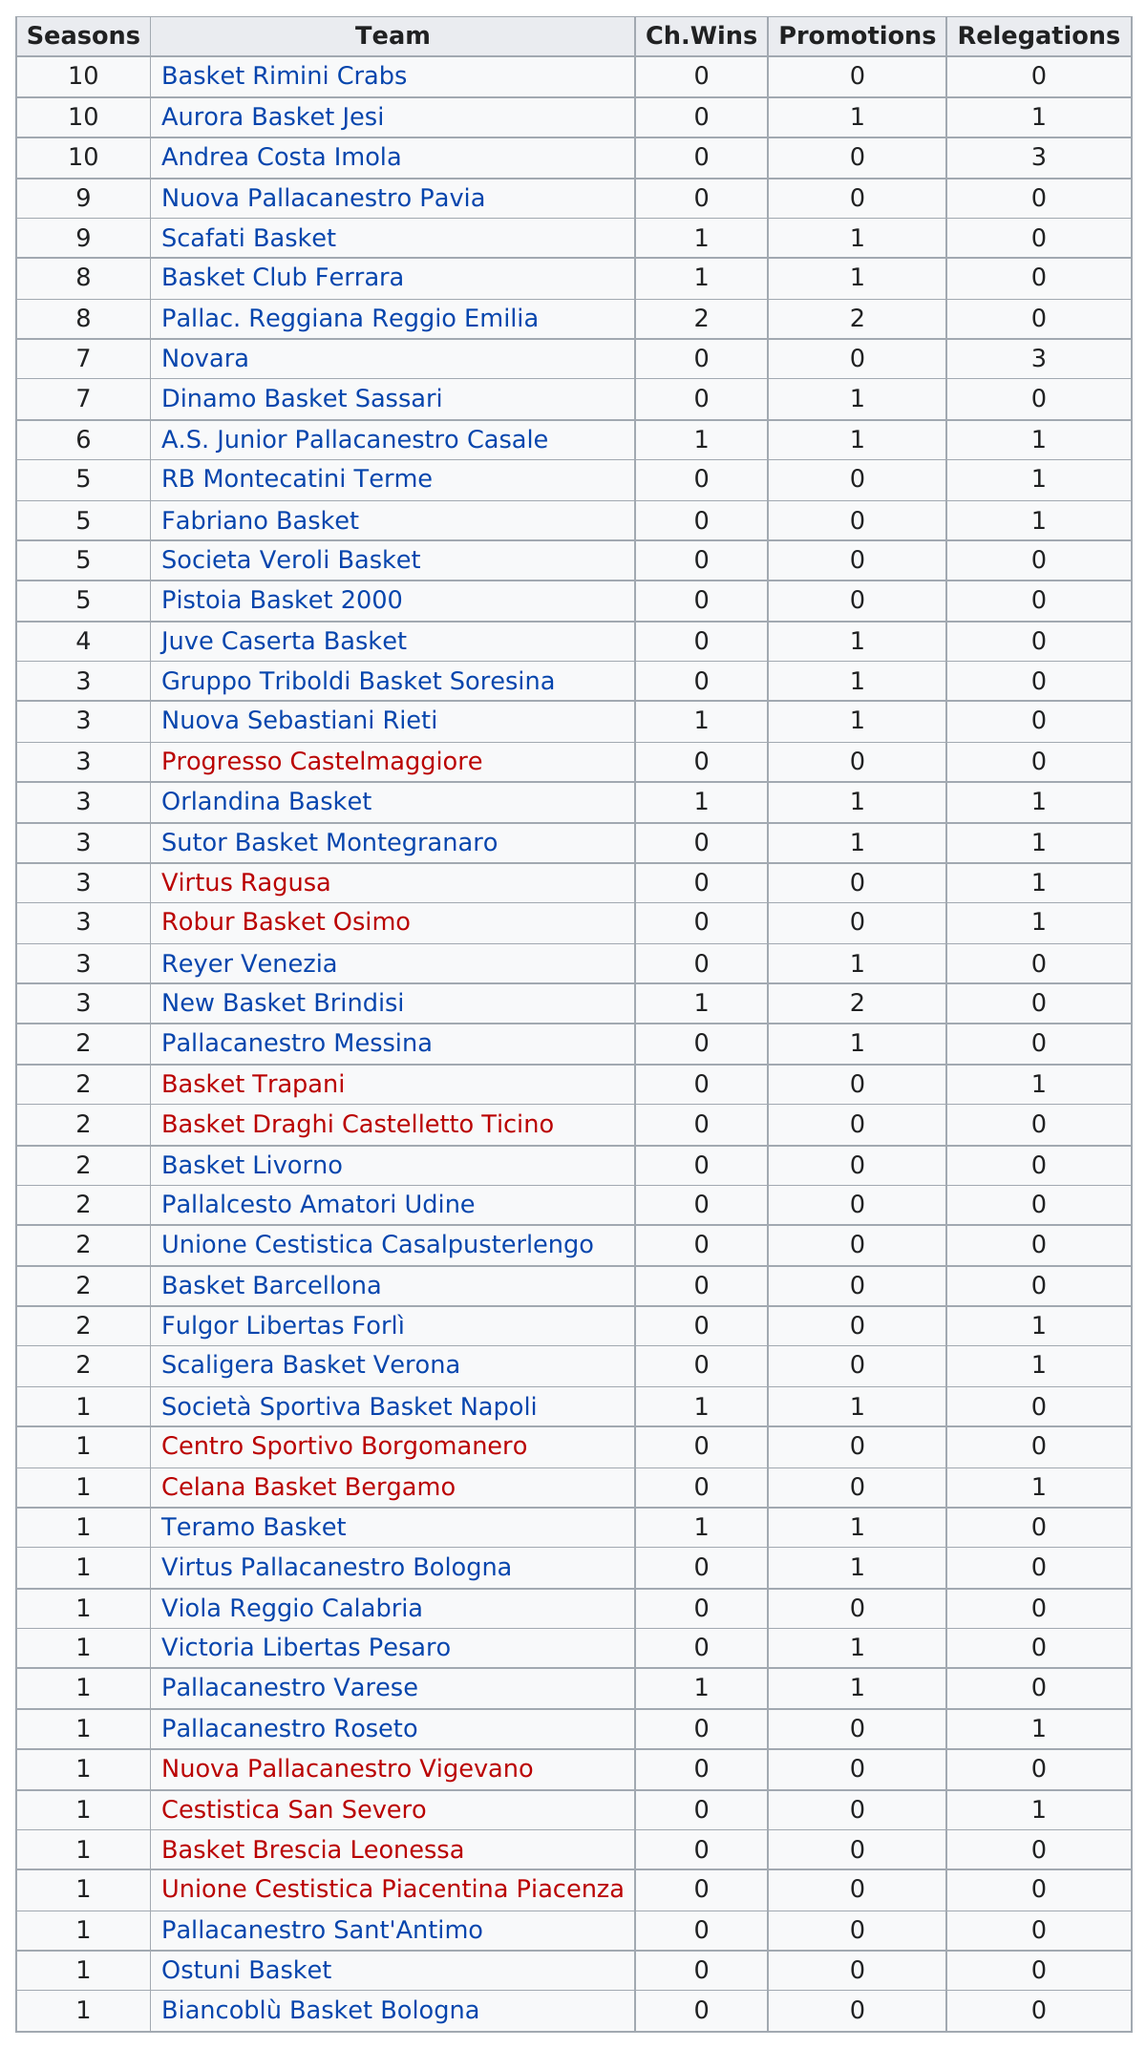Outline some significant characteristics in this image. Nuova Pallacanestro Pavia, besides Scafati basket, has appeared in 9 seasons. Pallacanestro Reggiana Reggio Emilia is the only team with two wins. There are 49 listed teams. Basket Rimini Crabs is a team that has not won any championships, promotions, or relegations. There are 16 teams that have the same number of promotions as Scafati Basket. 